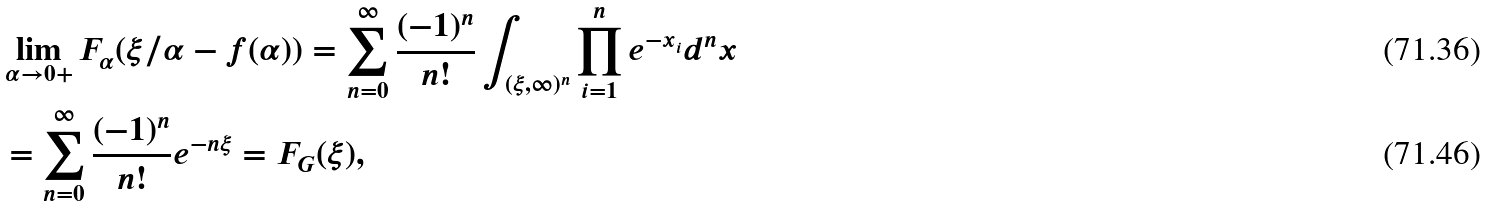Convert formula to latex. <formula><loc_0><loc_0><loc_500><loc_500>& \lim _ { \alpha \to 0 + } F _ { \alpha } ( \xi / \alpha - f ( \alpha ) ) = \sum _ { n = 0 } ^ { \infty } \frac { ( - 1 ) ^ { n } } { n ! } \int _ { ( \xi , \infty ) ^ { n } } \prod _ { i = 1 } ^ { n } e ^ { - x _ { i } } d ^ { n } x \\ & = \sum _ { n = 0 } ^ { \infty } \frac { ( - 1 ) ^ { n } } { n ! } e ^ { - n \xi } = F _ { G } ( \xi ) ,</formula> 